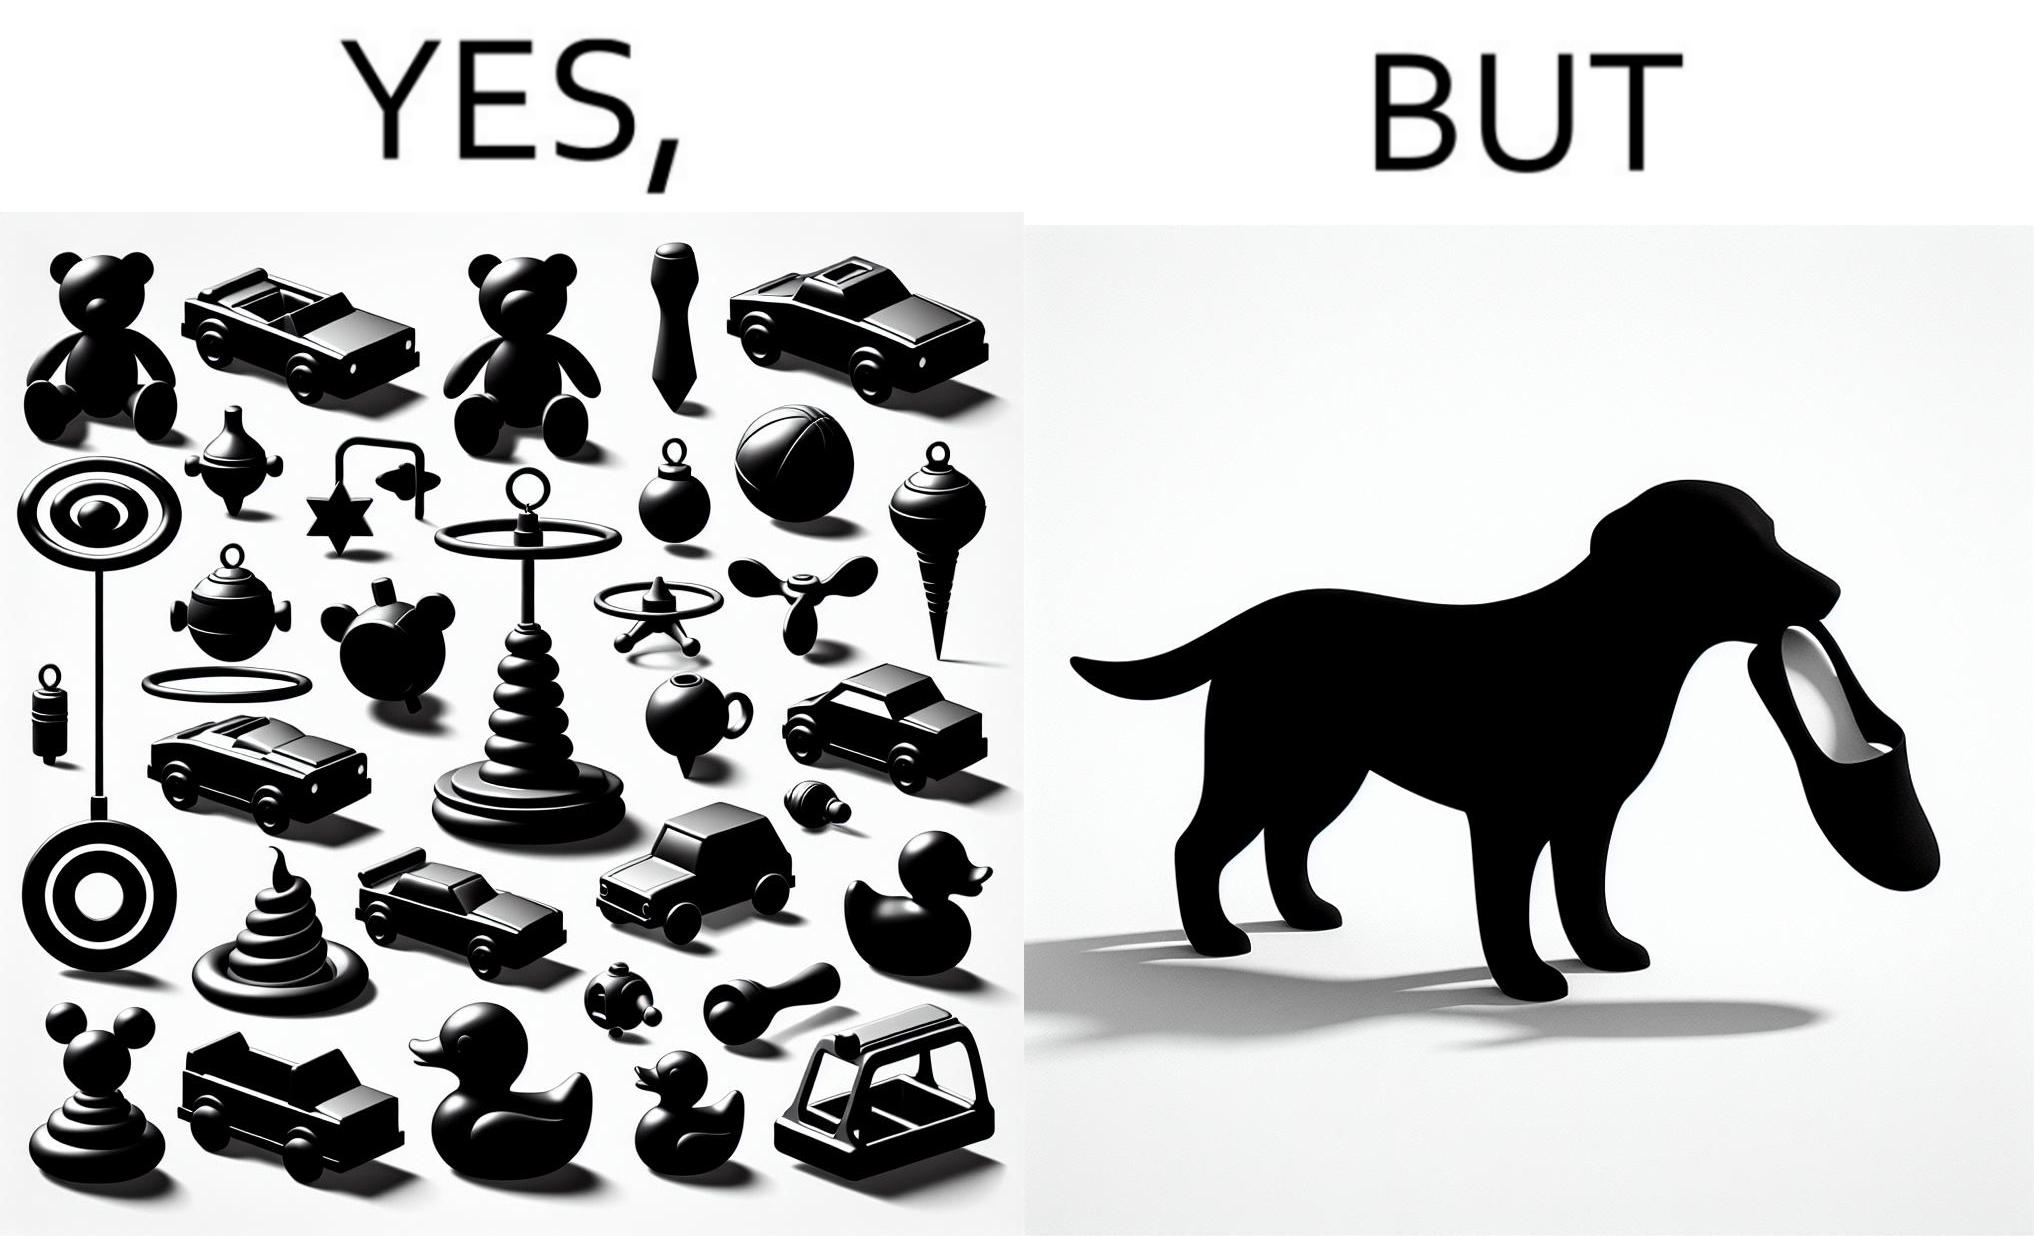Would you classify this image as satirical? Yes, this image is satirical. 